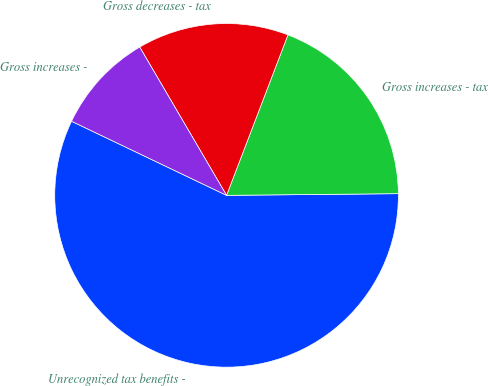<chart> <loc_0><loc_0><loc_500><loc_500><pie_chart><fcel>Unrecognized tax benefits -<fcel>Gross increases - tax<fcel>Gross decreases - tax<fcel>Gross increases -<nl><fcel>57.26%<fcel>19.03%<fcel>14.25%<fcel>9.47%<nl></chart> 